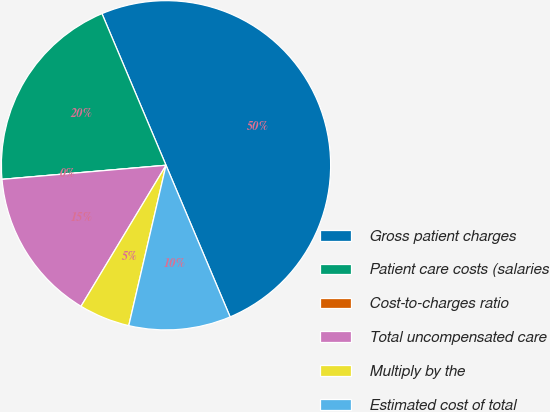Convert chart. <chart><loc_0><loc_0><loc_500><loc_500><pie_chart><fcel>Gross patient charges<fcel>Patient care costs (salaries<fcel>Cost-to-charges ratio<fcel>Total uncompensated care<fcel>Multiply by the<fcel>Estimated cost of total<nl><fcel>49.99%<fcel>20.0%<fcel>0.0%<fcel>15.0%<fcel>5.0%<fcel>10.0%<nl></chart> 